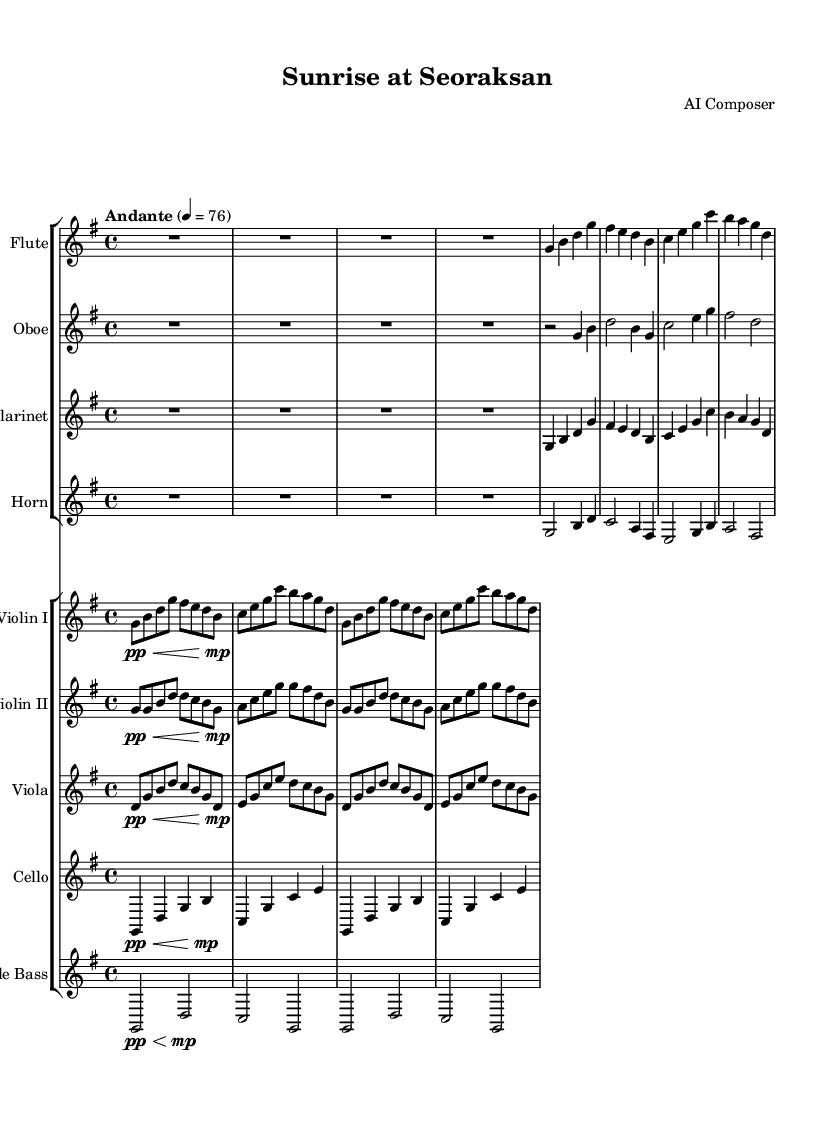What is the key signature of this music? The key signature is G major, which has one sharp (F#). This can be determined by looking at the key signature indicator at the beginning of the score, which shows the sharp.
Answer: G major What is the time signature of this music? The time signature is 4/4, indicating four beats per measure and a quarter note gets one beat. This information can be found next to the key signature at the start of the sheet music.
Answer: 4/4 What is the tempo marking for this piece? The tempo marking is "Andante," indicating a moderate slow tempo. This is indicated in the tempo section found near the beginning of the score, specifying how the piece should be performed.
Answer: Andante How many measures are in the first section of the piece? The first section of the piece contains four measures, as identified by counting the vertical lines (bar lines) that separate the measures in the score.
Answer: Four Which instrument has the highest pitch in this piece? The flute generally has the highest pitch among the instruments listed, as indicated by its provision for higher notes within the score. The range of the flute is higher compared to the other instruments.
Answer: Flute What type of ensemble is this music composed for? This music is composed for an orchestral ensemble, which is suggested by the presence of various sections including woodwinds, brass, strings, and percussion. The score layout shows multiple staves for different instruments typical of orchestral compositions.
Answer: Orchestral 